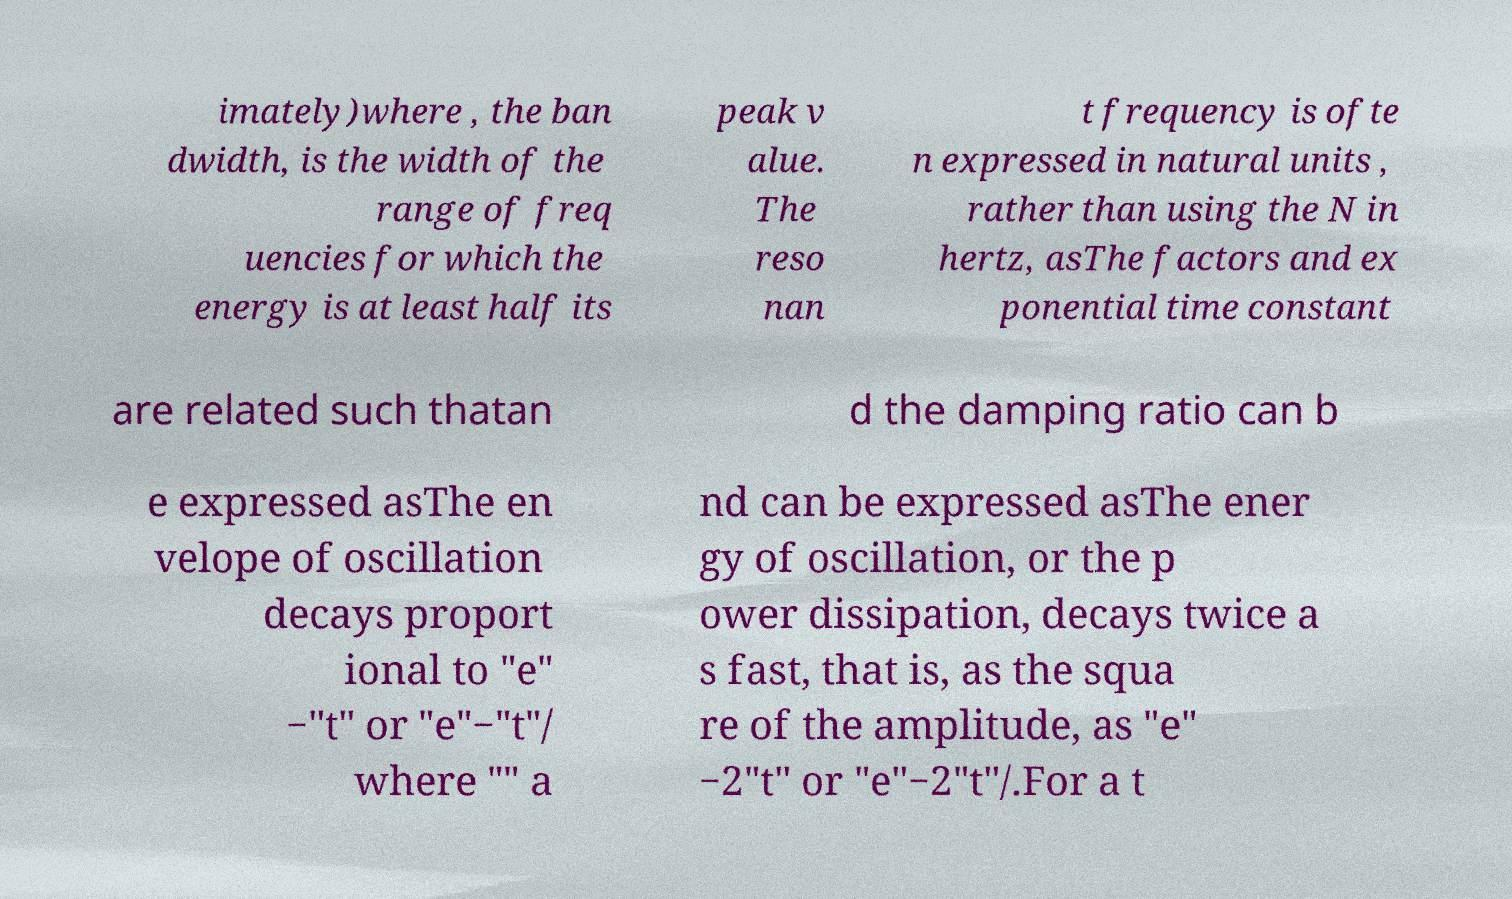Please read and relay the text visible in this image. What does it say? imately)where , the ban dwidth, is the width of the range of freq uencies for which the energy is at least half its peak v alue. The reso nan t frequency is ofte n expressed in natural units , rather than using the N in hertz, asThe factors and ex ponential time constant are related such thatan d the damping ratio can b e expressed asThe en velope of oscillation decays proport ional to "e" −"t" or "e"−"t"/ where "" a nd can be expressed asThe ener gy of oscillation, or the p ower dissipation, decays twice a s fast, that is, as the squa re of the amplitude, as "e" −2"t" or "e"−2"t"/.For a t 